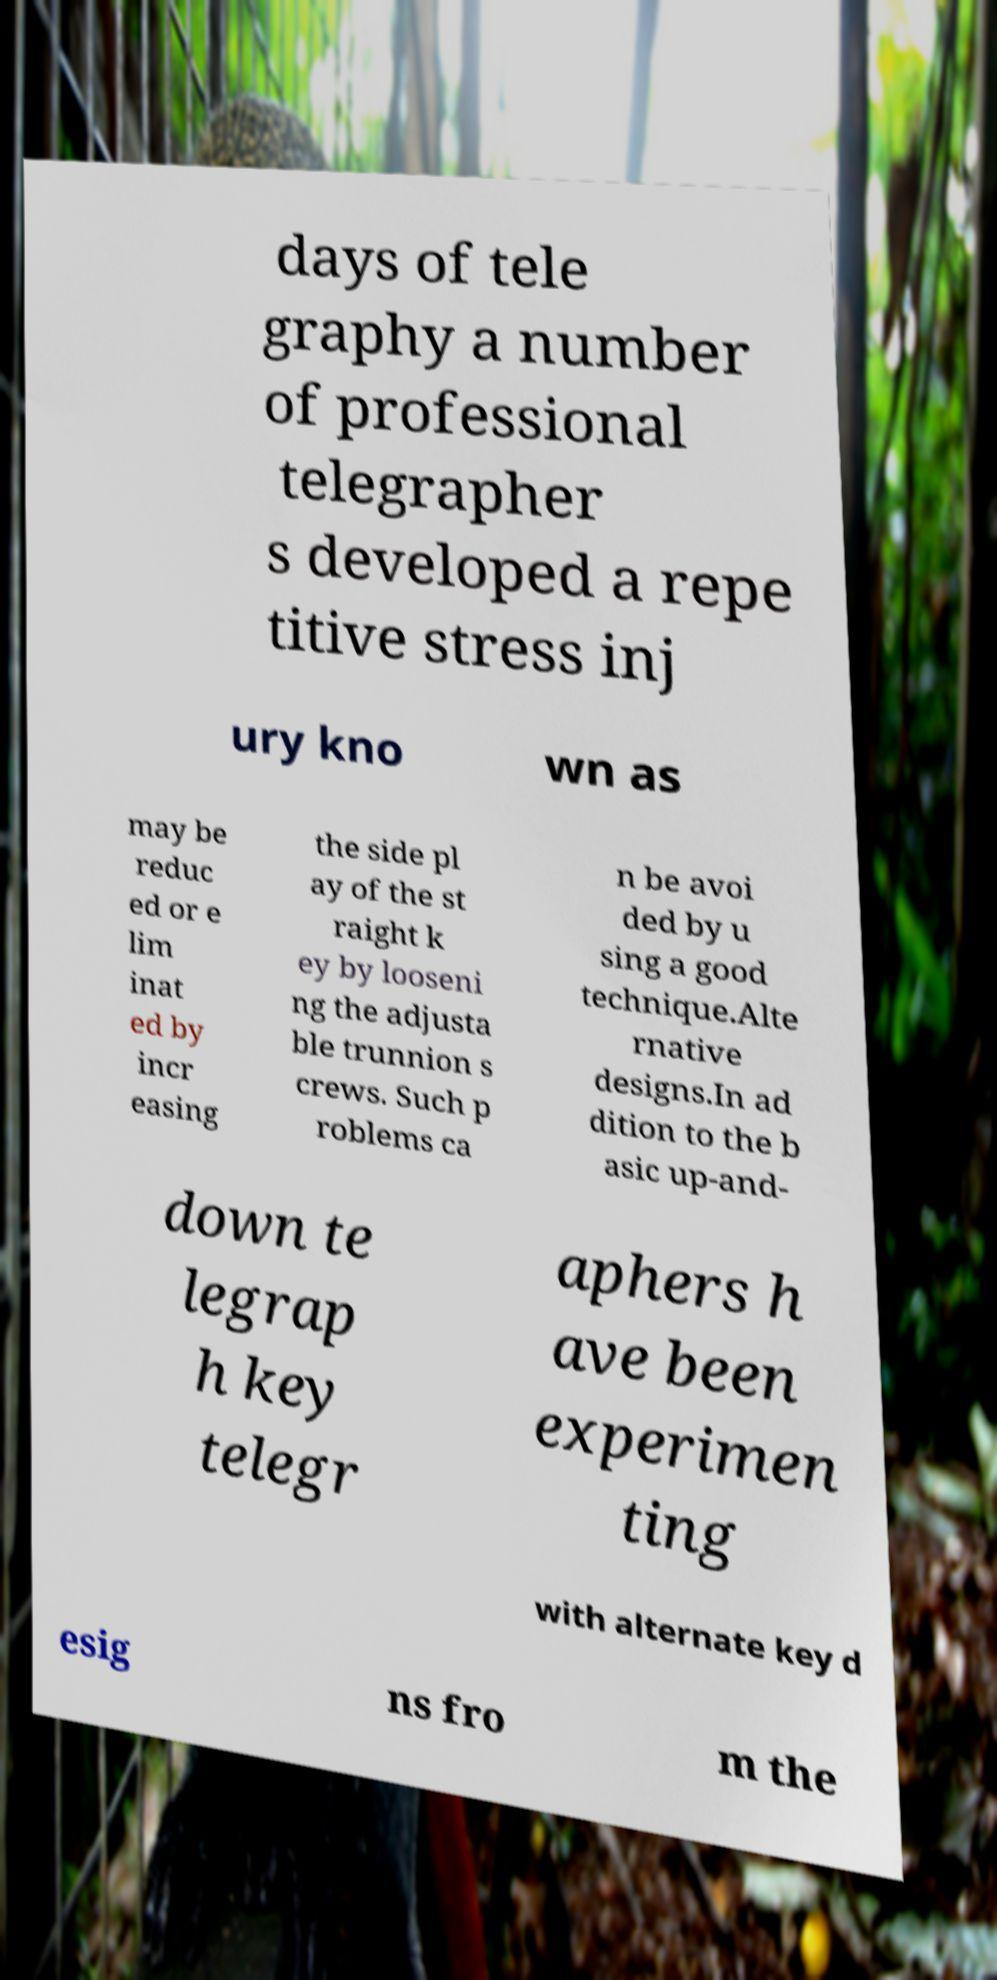Please identify and transcribe the text found in this image. days of tele graphy a number of professional telegrapher s developed a repe titive stress inj ury kno wn as may be reduc ed or e lim inat ed by incr easing the side pl ay of the st raight k ey by looseni ng the adjusta ble trunnion s crews. Such p roblems ca n be avoi ded by u sing a good technique.Alte rnative designs.In ad dition to the b asic up-and- down te legrap h key telegr aphers h ave been experimen ting with alternate key d esig ns fro m the 